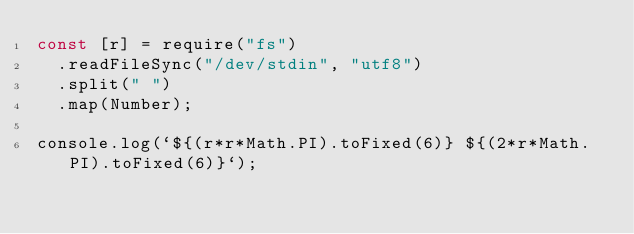<code> <loc_0><loc_0><loc_500><loc_500><_JavaScript_>const [r] = require("fs")
  .readFileSync("/dev/stdin", "utf8")
  .split(" ")
  .map(Number);

console.log(`${(r*r*Math.PI).toFixed(6)} ${(2*r*Math.PI).toFixed(6)}`);

</code> 